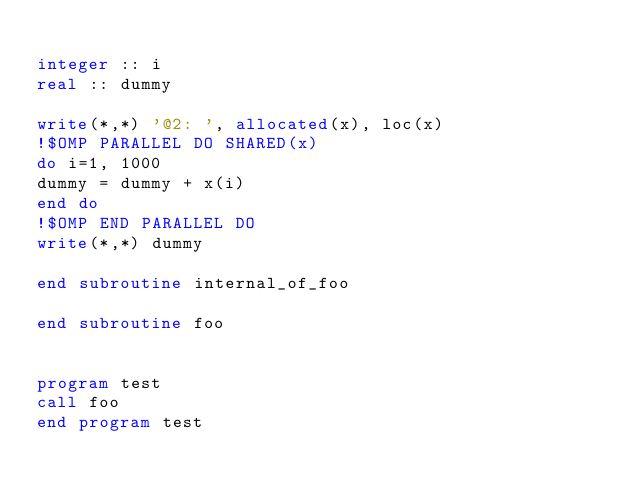Convert code to text. <code><loc_0><loc_0><loc_500><loc_500><_FORTRAN_>
integer :: i
real :: dummy

write(*,*) '@2: ', allocated(x), loc(x) 
!$OMP PARALLEL DO SHARED(x)
do i=1, 1000
dummy = dummy + x(i)
end do
!$OMP END PARALLEL DO
write(*,*) dummy

end subroutine internal_of_foo

end subroutine foo


program test
call foo
end program test

</code> 